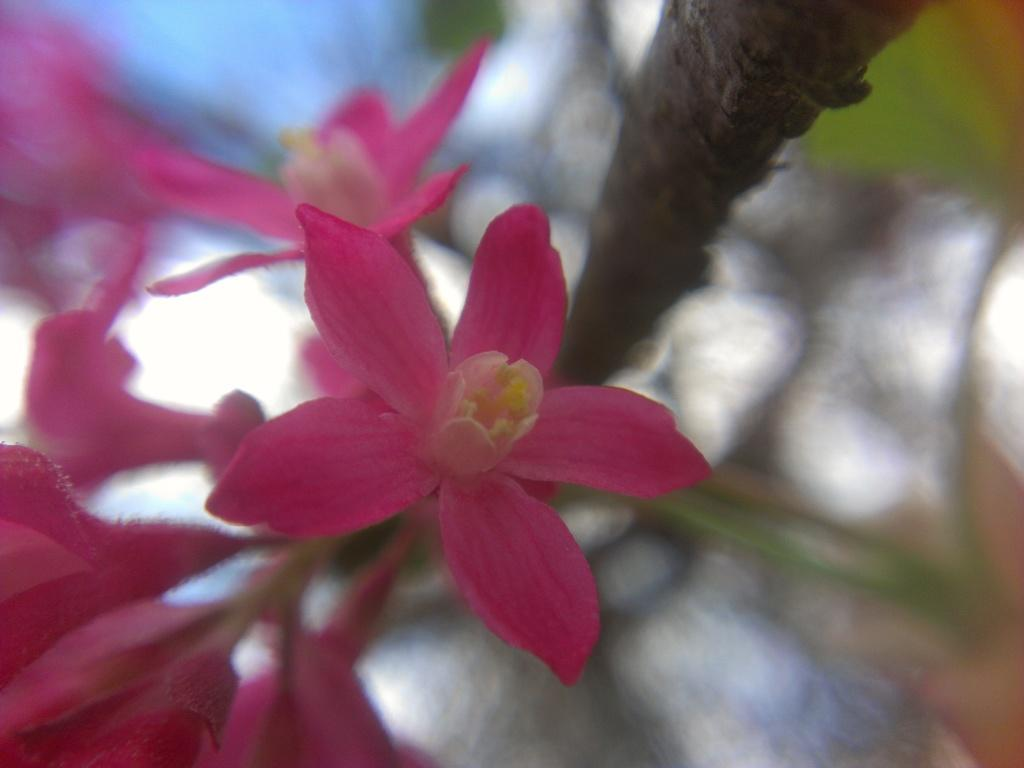Where was the image taken? The image is taken outdoors. What can be seen in the image besides the outdoor setting? There is a plant and flowers in the image. Can you describe the flowers in the image? The flowers are on the left side of the image and are pink in color. Is there a throne made of flowers in the image? No, there is no throne present in the image. 